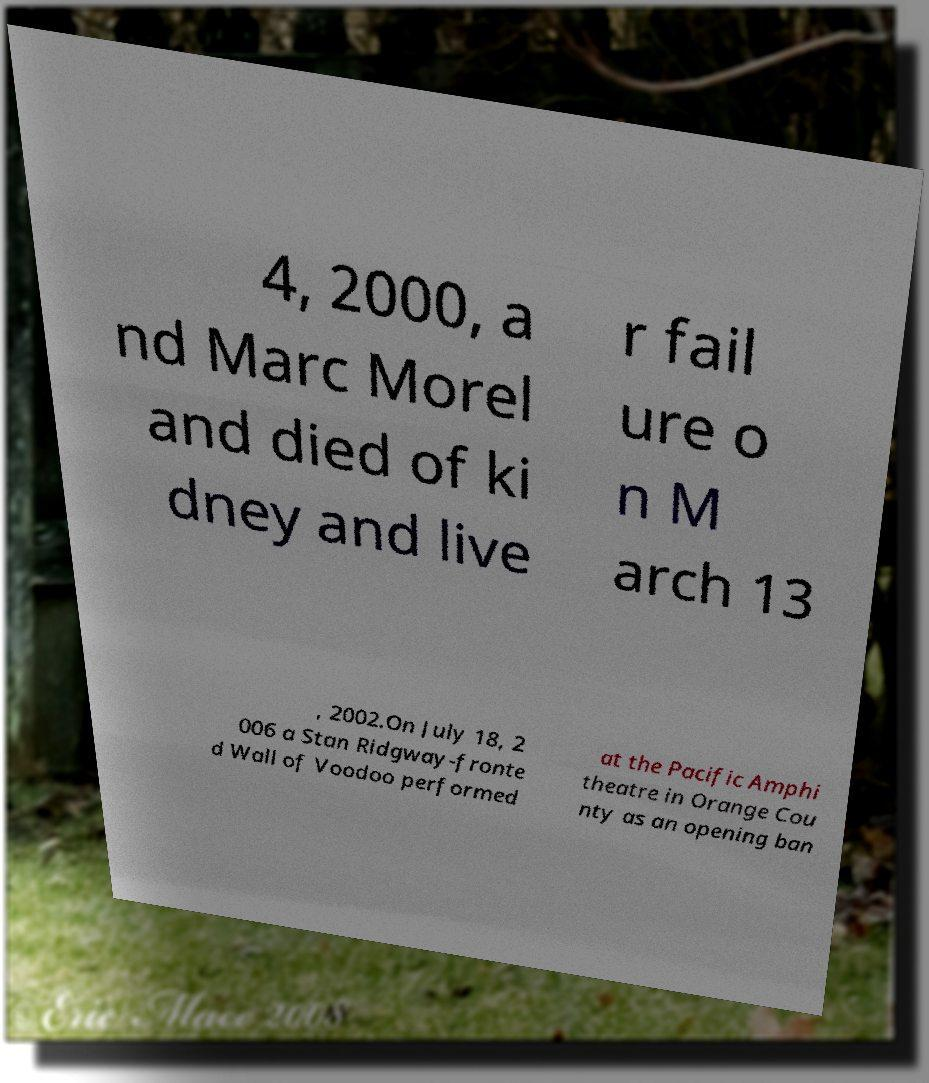Could you extract and type out the text from this image? 4, 2000, a nd Marc Morel and died of ki dney and live r fail ure o n M arch 13 , 2002.On July 18, 2 006 a Stan Ridgway-fronte d Wall of Voodoo performed at the Pacific Amphi theatre in Orange Cou nty as an opening ban 